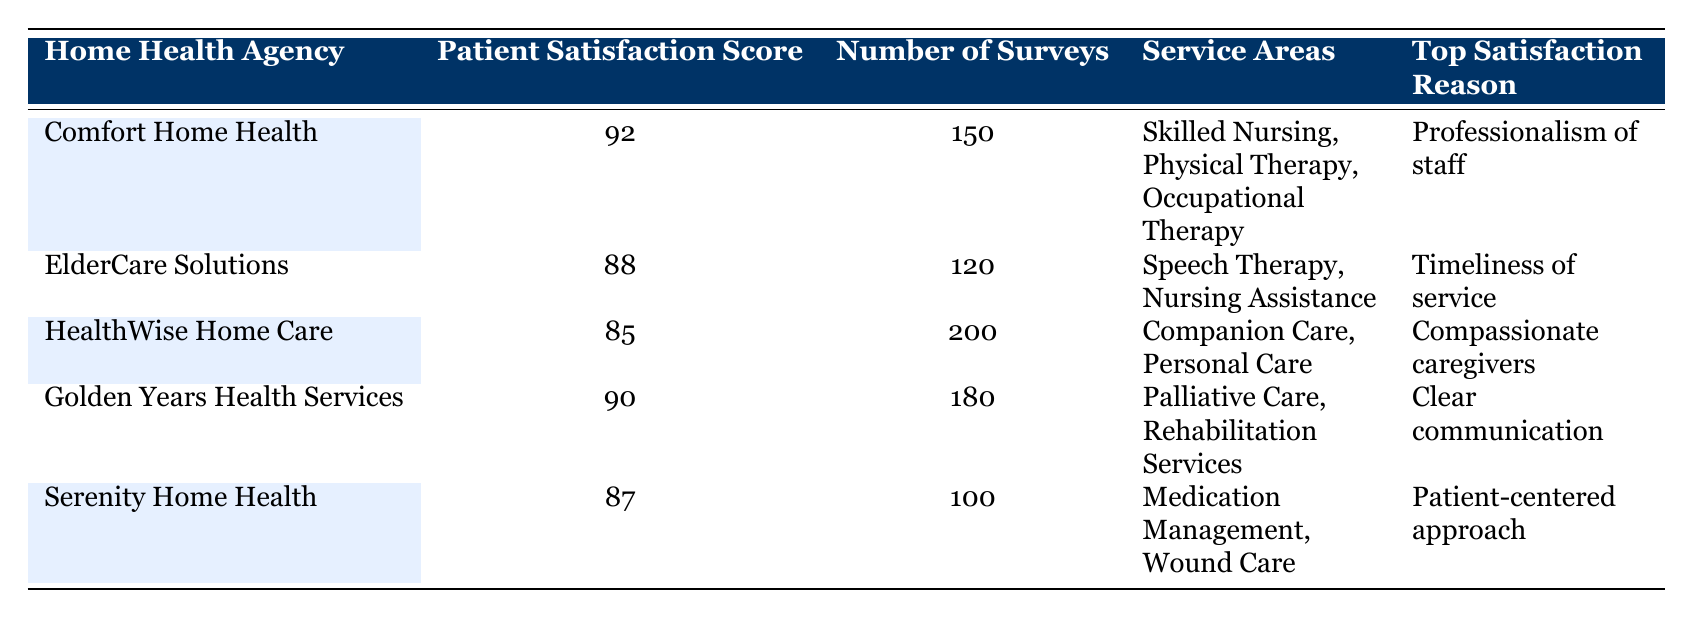What is the Patient Satisfaction Score for Comfort Home Health? The table shows that the Patient Satisfaction Score for Comfort Home Health is listed directly in the column adjacent to the agency name, which is 92.
Answer: 92 Which agency has the highest Patient Satisfaction Score? By comparing the Patient Satisfaction Scores listed in the table, Comfort Home Health has the highest score at 92.
Answer: Comfort Home Health How many surveys were conducted by HealthWise Home Care? The Number of Surveys column for HealthWise Home Care shows that 200 surveys were conducted.
Answer: 200 What is the Top Satisfaction Reason for Serenity Home Health? By looking at the Top Satisfaction Reason column for Serenity Home Health, it can be seen that the reason is 'Patient-centered approach.'
Answer: Patient-centered approach What is the average Patient Satisfaction Score of the agencies listed in the table? The Patient Satisfaction Scores are 92, 88, 85, 90, and 87. Adding these together gives 442, and dividing by the number of agencies (5) results in an average of 442/5 = 88.4.
Answer: 88.4 Is there a home health agency with a Patient Satisfaction Score below 86? By checking the Patient Satisfaction Scores, HealthWise Home Care at 85 has a score below 86. Therefore, the answer is yes.
Answer: Yes Which agency provides Skilled Nursing services and what is its Patient Satisfaction Score? The table shows that Comfort Home Health provides Skilled Nursing services and has a Patient Satisfaction Score of 92.
Answer: Comfort Home Health, 92 Are there any agencies with a Patient Satisfaction Score of 90 or above? Checking the Patient Satisfaction Scores, Comfort Home Health (92) and Golden Years Health Services (90) both meet this criterion, confirming that the statement is true.
Answer: Yes What is the total number of surveys conducted across all agencies? To get the total number of surveys, we add the Number of Surveys: 150 + 120 + 200 + 180 + 100 = 850.
Answer: 850 What percentage of surveys for ElderCare Solutions rated it as satisfactory? ElderCare Solutions had a Patient Satisfaction Score of 88 based on 120 surveys. Therefore, to find the percentage: (88/100) * 120 = 105.6 rounded to an approximation of 88%.
Answer: 88% 